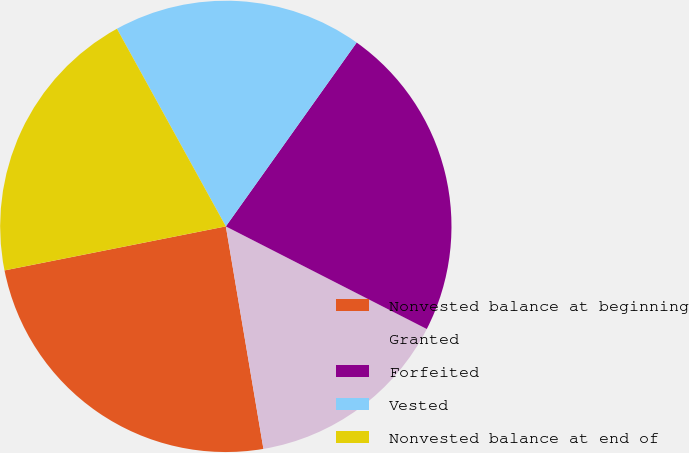<chart> <loc_0><loc_0><loc_500><loc_500><pie_chart><fcel>Nonvested balance at beginning<fcel>Granted<fcel>Forfeited<fcel>Vested<fcel>Nonvested balance at end of<nl><fcel>24.54%<fcel>14.82%<fcel>22.67%<fcel>17.86%<fcel>20.11%<nl></chart> 